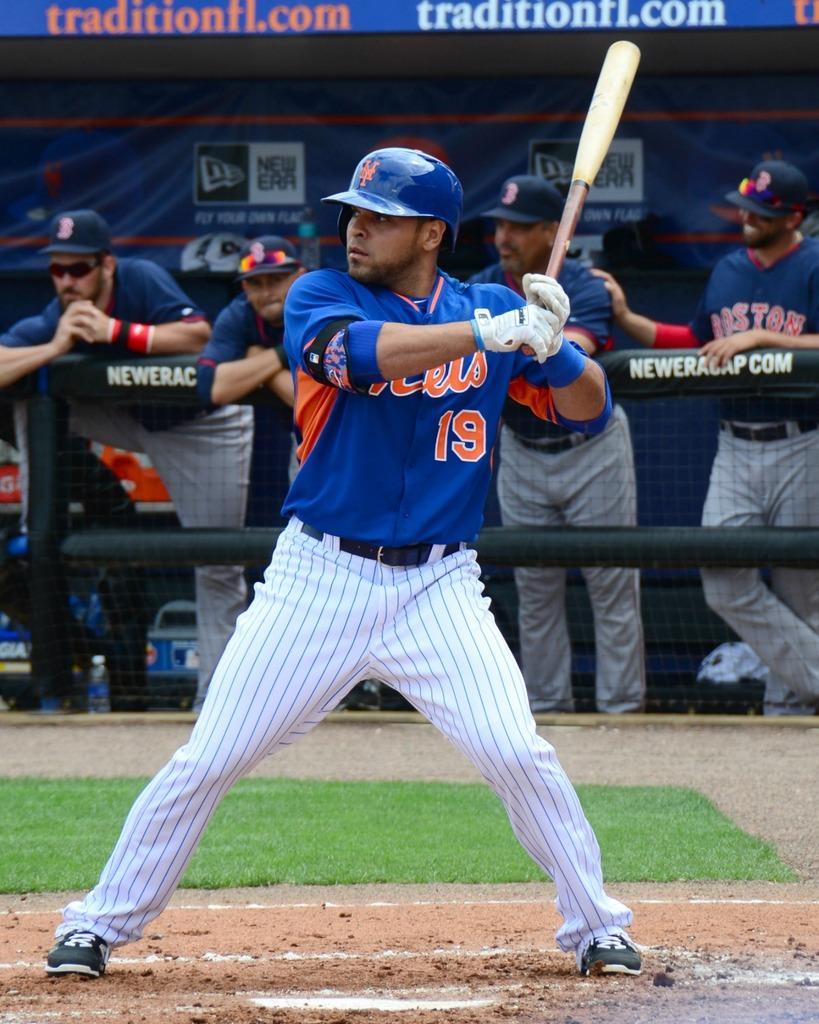<image>
Summarize the visual content of the image. Several Boston Red Sox players watch as  Mets player is up to bat. 